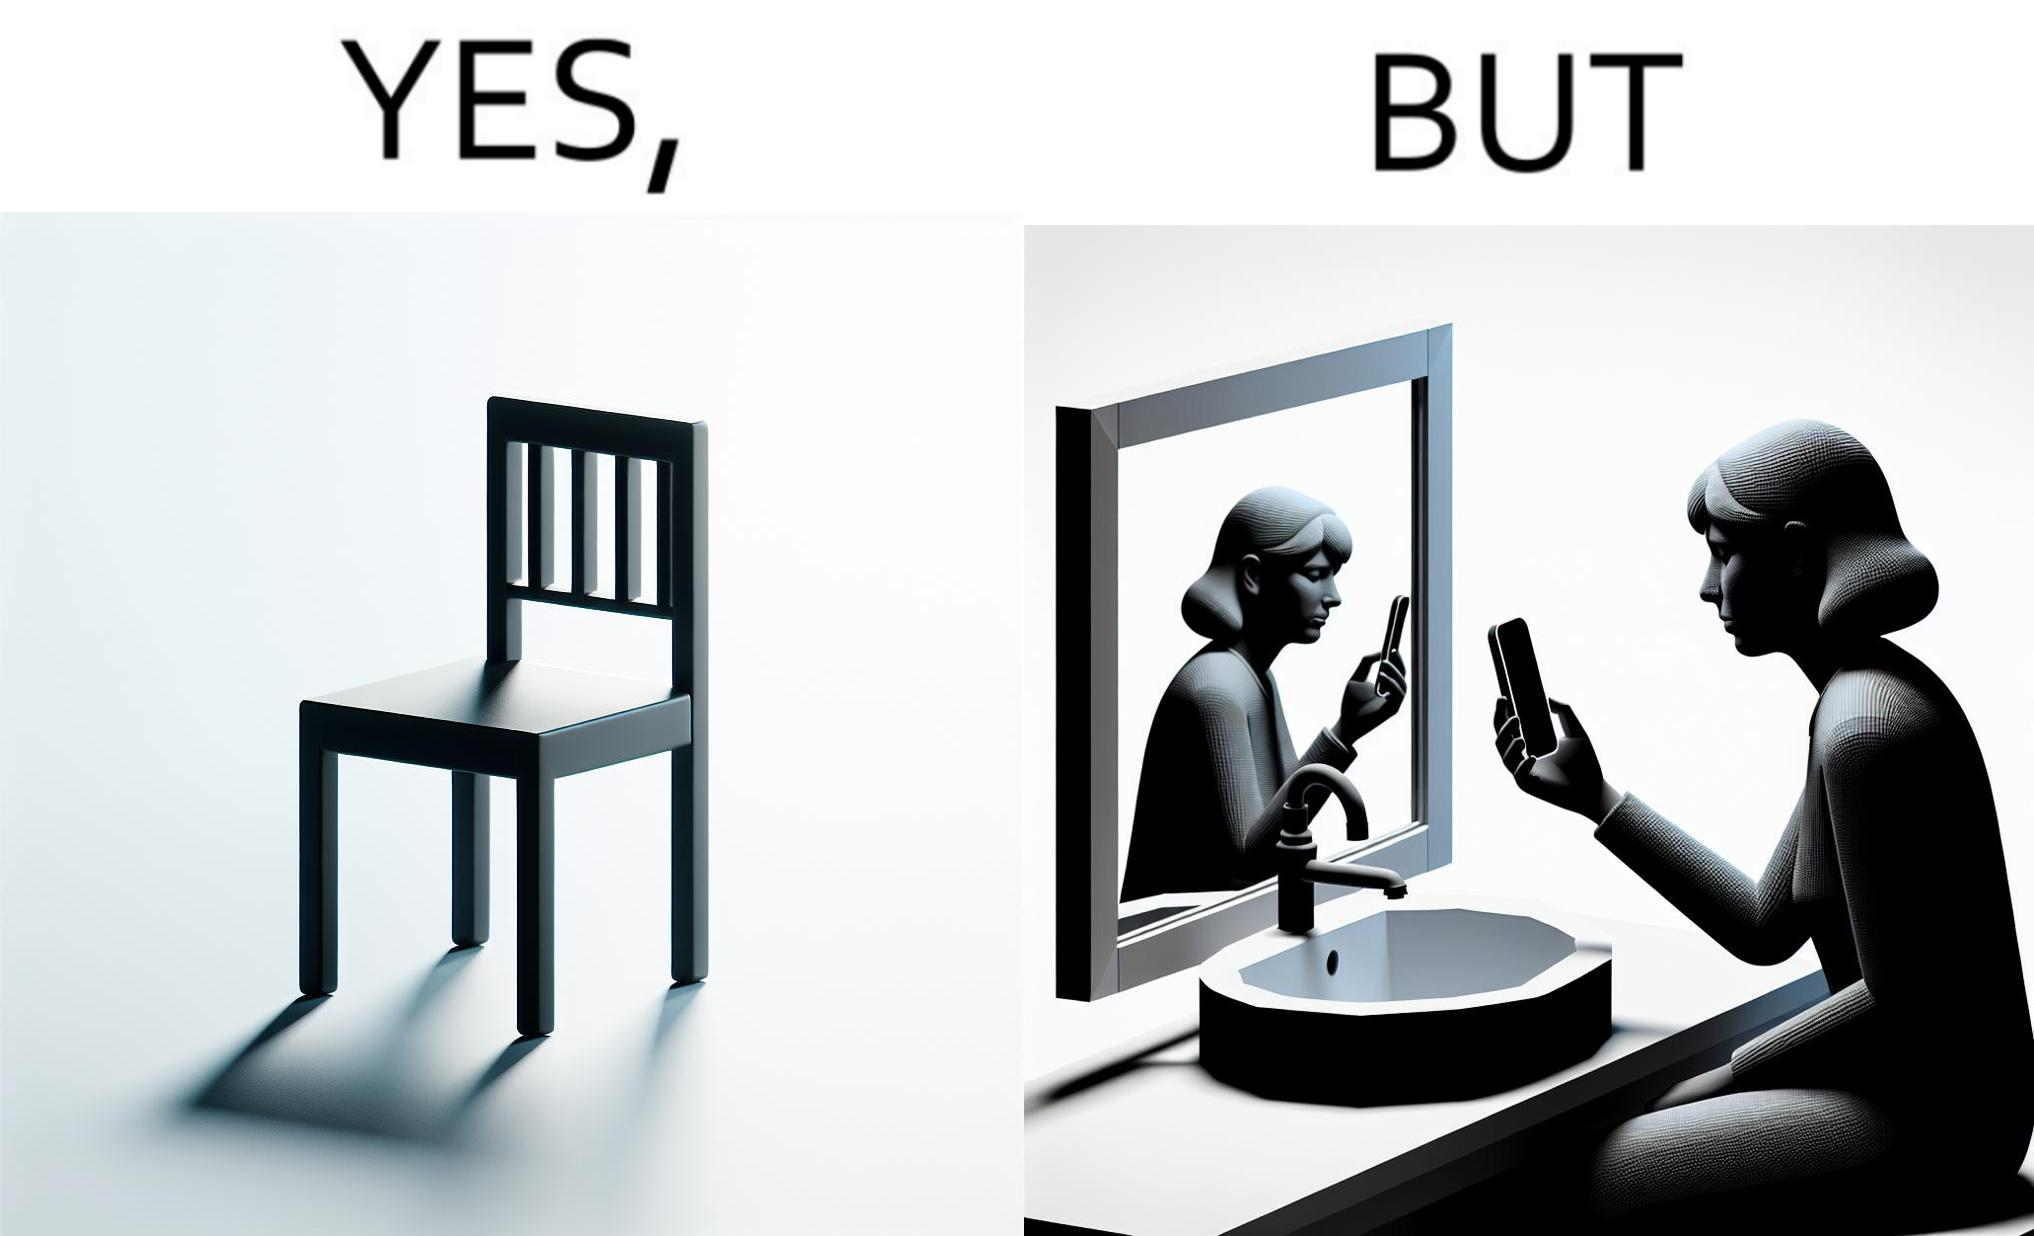Why is this image considered satirical? The image is ironical, as a woman is sitting by the sink taking a selfie using a mirror, while not using a chair that is actually meant for sitting. 